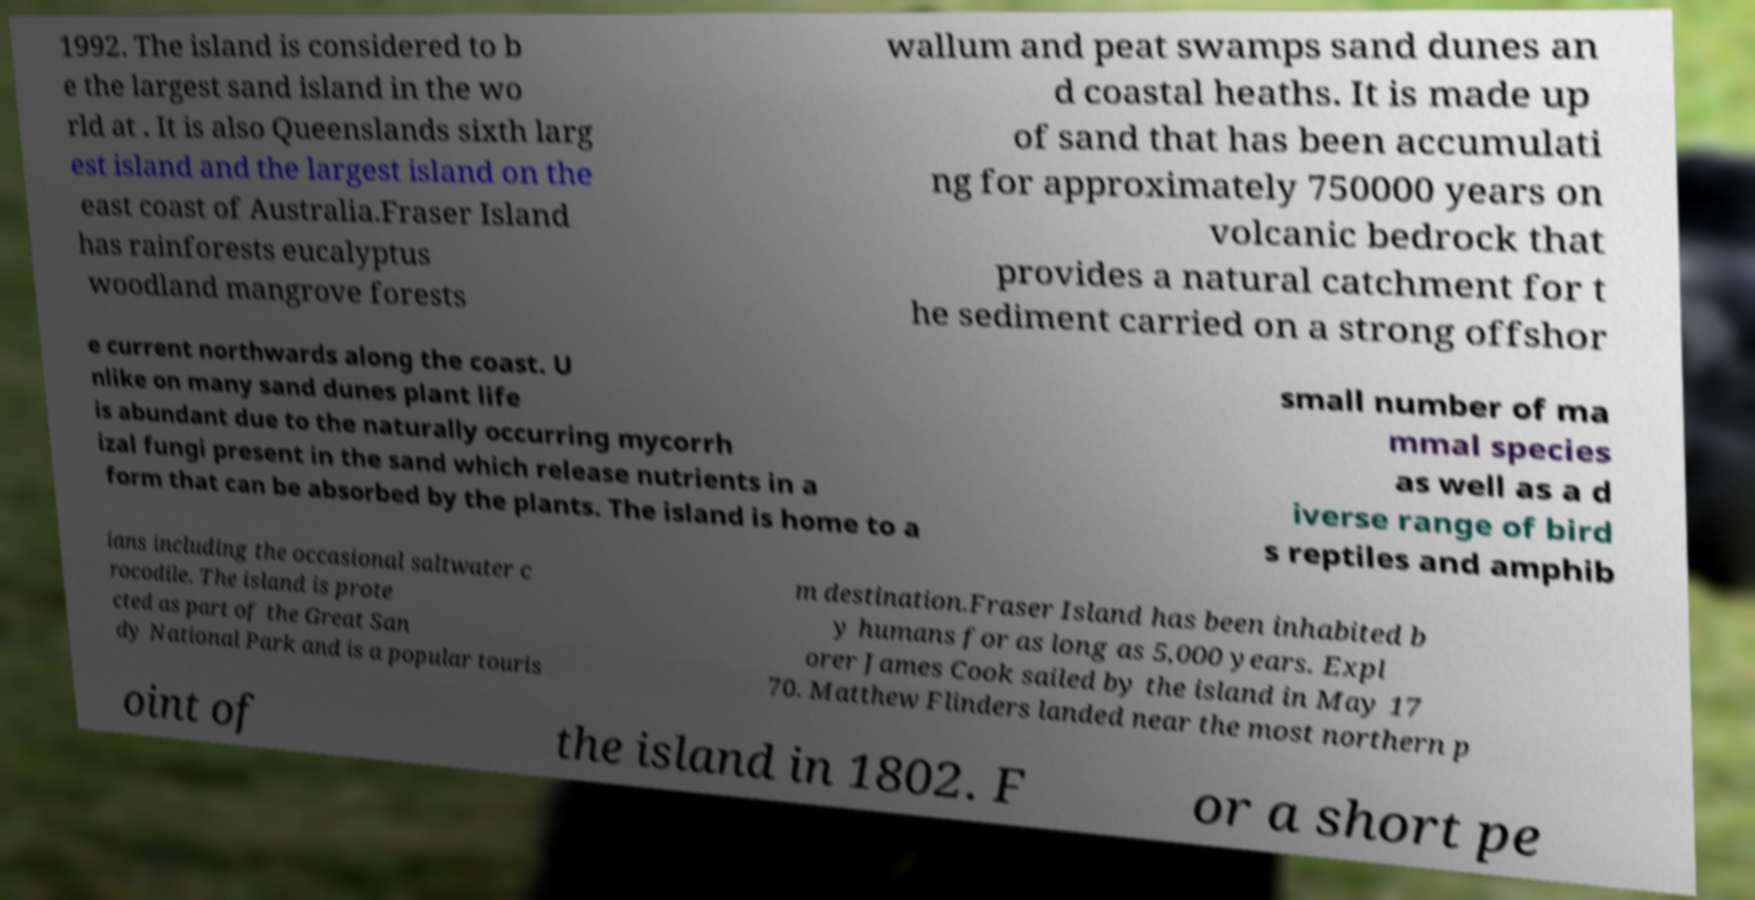Please read and relay the text visible in this image. What does it say? 1992. The island is considered to b e the largest sand island in the wo rld at . It is also Queenslands sixth larg est island and the largest island on the east coast of Australia.Fraser Island has rainforests eucalyptus woodland mangrove forests wallum and peat swamps sand dunes an d coastal heaths. It is made up of sand that has been accumulati ng for approximately 750000 years on volcanic bedrock that provides a natural catchment for t he sediment carried on a strong offshor e current northwards along the coast. U nlike on many sand dunes plant life is abundant due to the naturally occurring mycorrh izal fungi present in the sand which release nutrients in a form that can be absorbed by the plants. The island is home to a small number of ma mmal species as well as a d iverse range of bird s reptiles and amphib ians including the occasional saltwater c rocodile. The island is prote cted as part of the Great San dy National Park and is a popular touris m destination.Fraser Island has been inhabited b y humans for as long as 5,000 years. Expl orer James Cook sailed by the island in May 17 70. Matthew Flinders landed near the most northern p oint of the island in 1802. F or a short pe 